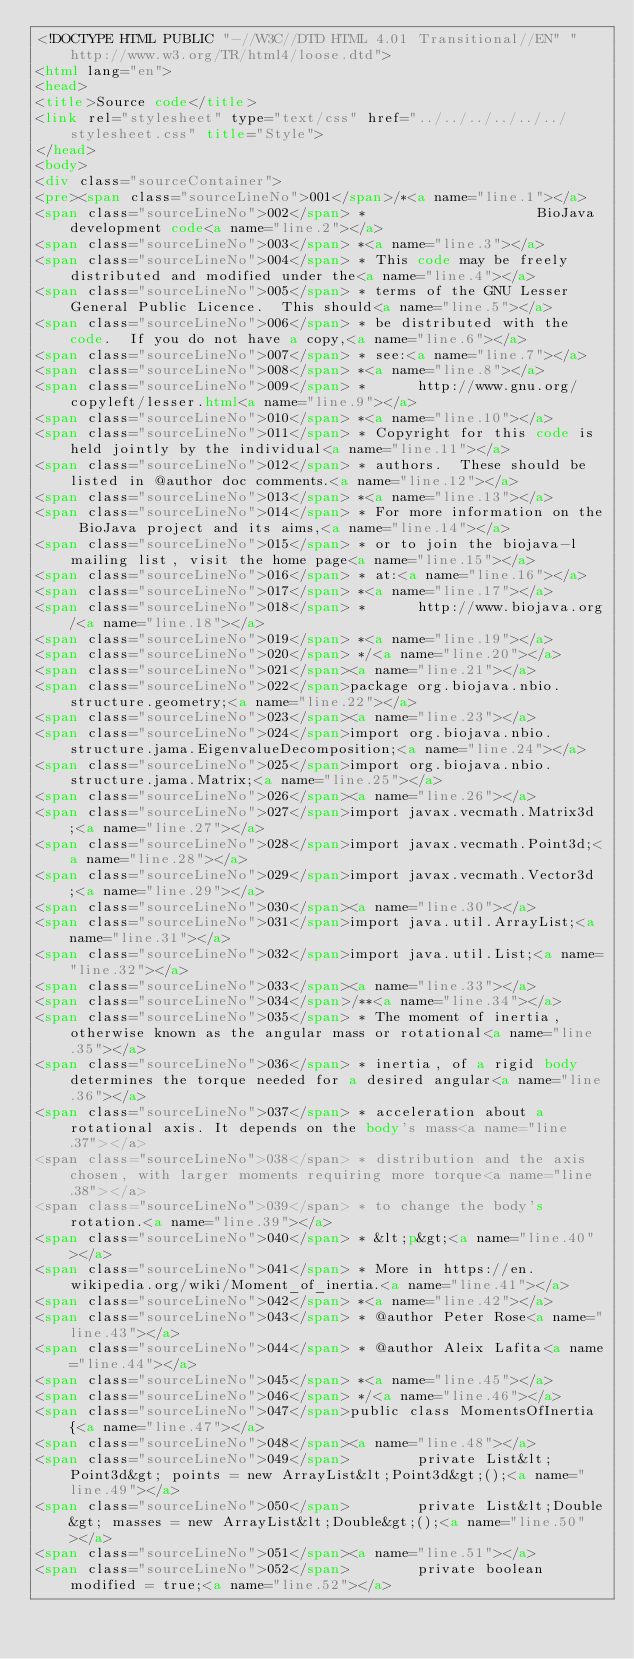<code> <loc_0><loc_0><loc_500><loc_500><_HTML_><!DOCTYPE HTML PUBLIC "-//W3C//DTD HTML 4.01 Transitional//EN" "http://www.w3.org/TR/html4/loose.dtd">
<html lang="en">
<head>
<title>Source code</title>
<link rel="stylesheet" type="text/css" href="../../../../../../stylesheet.css" title="Style">
</head>
<body>
<div class="sourceContainer">
<pre><span class="sourceLineNo">001</span>/*<a name="line.1"></a>
<span class="sourceLineNo">002</span> *                    BioJava development code<a name="line.2"></a>
<span class="sourceLineNo">003</span> *<a name="line.3"></a>
<span class="sourceLineNo">004</span> * This code may be freely distributed and modified under the<a name="line.4"></a>
<span class="sourceLineNo">005</span> * terms of the GNU Lesser General Public Licence.  This should<a name="line.5"></a>
<span class="sourceLineNo">006</span> * be distributed with the code.  If you do not have a copy,<a name="line.6"></a>
<span class="sourceLineNo">007</span> * see:<a name="line.7"></a>
<span class="sourceLineNo">008</span> *<a name="line.8"></a>
<span class="sourceLineNo">009</span> *      http://www.gnu.org/copyleft/lesser.html<a name="line.9"></a>
<span class="sourceLineNo">010</span> *<a name="line.10"></a>
<span class="sourceLineNo">011</span> * Copyright for this code is held jointly by the individual<a name="line.11"></a>
<span class="sourceLineNo">012</span> * authors.  These should be listed in @author doc comments.<a name="line.12"></a>
<span class="sourceLineNo">013</span> *<a name="line.13"></a>
<span class="sourceLineNo">014</span> * For more information on the BioJava project and its aims,<a name="line.14"></a>
<span class="sourceLineNo">015</span> * or to join the biojava-l mailing list, visit the home page<a name="line.15"></a>
<span class="sourceLineNo">016</span> * at:<a name="line.16"></a>
<span class="sourceLineNo">017</span> *<a name="line.17"></a>
<span class="sourceLineNo">018</span> *      http://www.biojava.org/<a name="line.18"></a>
<span class="sourceLineNo">019</span> *<a name="line.19"></a>
<span class="sourceLineNo">020</span> */<a name="line.20"></a>
<span class="sourceLineNo">021</span><a name="line.21"></a>
<span class="sourceLineNo">022</span>package org.biojava.nbio.structure.geometry;<a name="line.22"></a>
<span class="sourceLineNo">023</span><a name="line.23"></a>
<span class="sourceLineNo">024</span>import org.biojava.nbio.structure.jama.EigenvalueDecomposition;<a name="line.24"></a>
<span class="sourceLineNo">025</span>import org.biojava.nbio.structure.jama.Matrix;<a name="line.25"></a>
<span class="sourceLineNo">026</span><a name="line.26"></a>
<span class="sourceLineNo">027</span>import javax.vecmath.Matrix3d;<a name="line.27"></a>
<span class="sourceLineNo">028</span>import javax.vecmath.Point3d;<a name="line.28"></a>
<span class="sourceLineNo">029</span>import javax.vecmath.Vector3d;<a name="line.29"></a>
<span class="sourceLineNo">030</span><a name="line.30"></a>
<span class="sourceLineNo">031</span>import java.util.ArrayList;<a name="line.31"></a>
<span class="sourceLineNo">032</span>import java.util.List;<a name="line.32"></a>
<span class="sourceLineNo">033</span><a name="line.33"></a>
<span class="sourceLineNo">034</span>/**<a name="line.34"></a>
<span class="sourceLineNo">035</span> * The moment of inertia, otherwise known as the angular mass or rotational<a name="line.35"></a>
<span class="sourceLineNo">036</span> * inertia, of a rigid body determines the torque needed for a desired angular<a name="line.36"></a>
<span class="sourceLineNo">037</span> * acceleration about a rotational axis. It depends on the body's mass<a name="line.37"></a>
<span class="sourceLineNo">038</span> * distribution and the axis chosen, with larger moments requiring more torque<a name="line.38"></a>
<span class="sourceLineNo">039</span> * to change the body's rotation.<a name="line.39"></a>
<span class="sourceLineNo">040</span> * &lt;p&gt;<a name="line.40"></a>
<span class="sourceLineNo">041</span> * More in https://en.wikipedia.org/wiki/Moment_of_inertia.<a name="line.41"></a>
<span class="sourceLineNo">042</span> *<a name="line.42"></a>
<span class="sourceLineNo">043</span> * @author Peter Rose<a name="line.43"></a>
<span class="sourceLineNo">044</span> * @author Aleix Lafita<a name="line.44"></a>
<span class="sourceLineNo">045</span> *<a name="line.45"></a>
<span class="sourceLineNo">046</span> */<a name="line.46"></a>
<span class="sourceLineNo">047</span>public class MomentsOfInertia {<a name="line.47"></a>
<span class="sourceLineNo">048</span><a name="line.48"></a>
<span class="sourceLineNo">049</span>        private List&lt;Point3d&gt; points = new ArrayList&lt;Point3d&gt;();<a name="line.49"></a>
<span class="sourceLineNo">050</span>        private List&lt;Double&gt; masses = new ArrayList&lt;Double&gt;();<a name="line.50"></a>
<span class="sourceLineNo">051</span><a name="line.51"></a>
<span class="sourceLineNo">052</span>        private boolean modified = true;<a name="line.52"></a></code> 